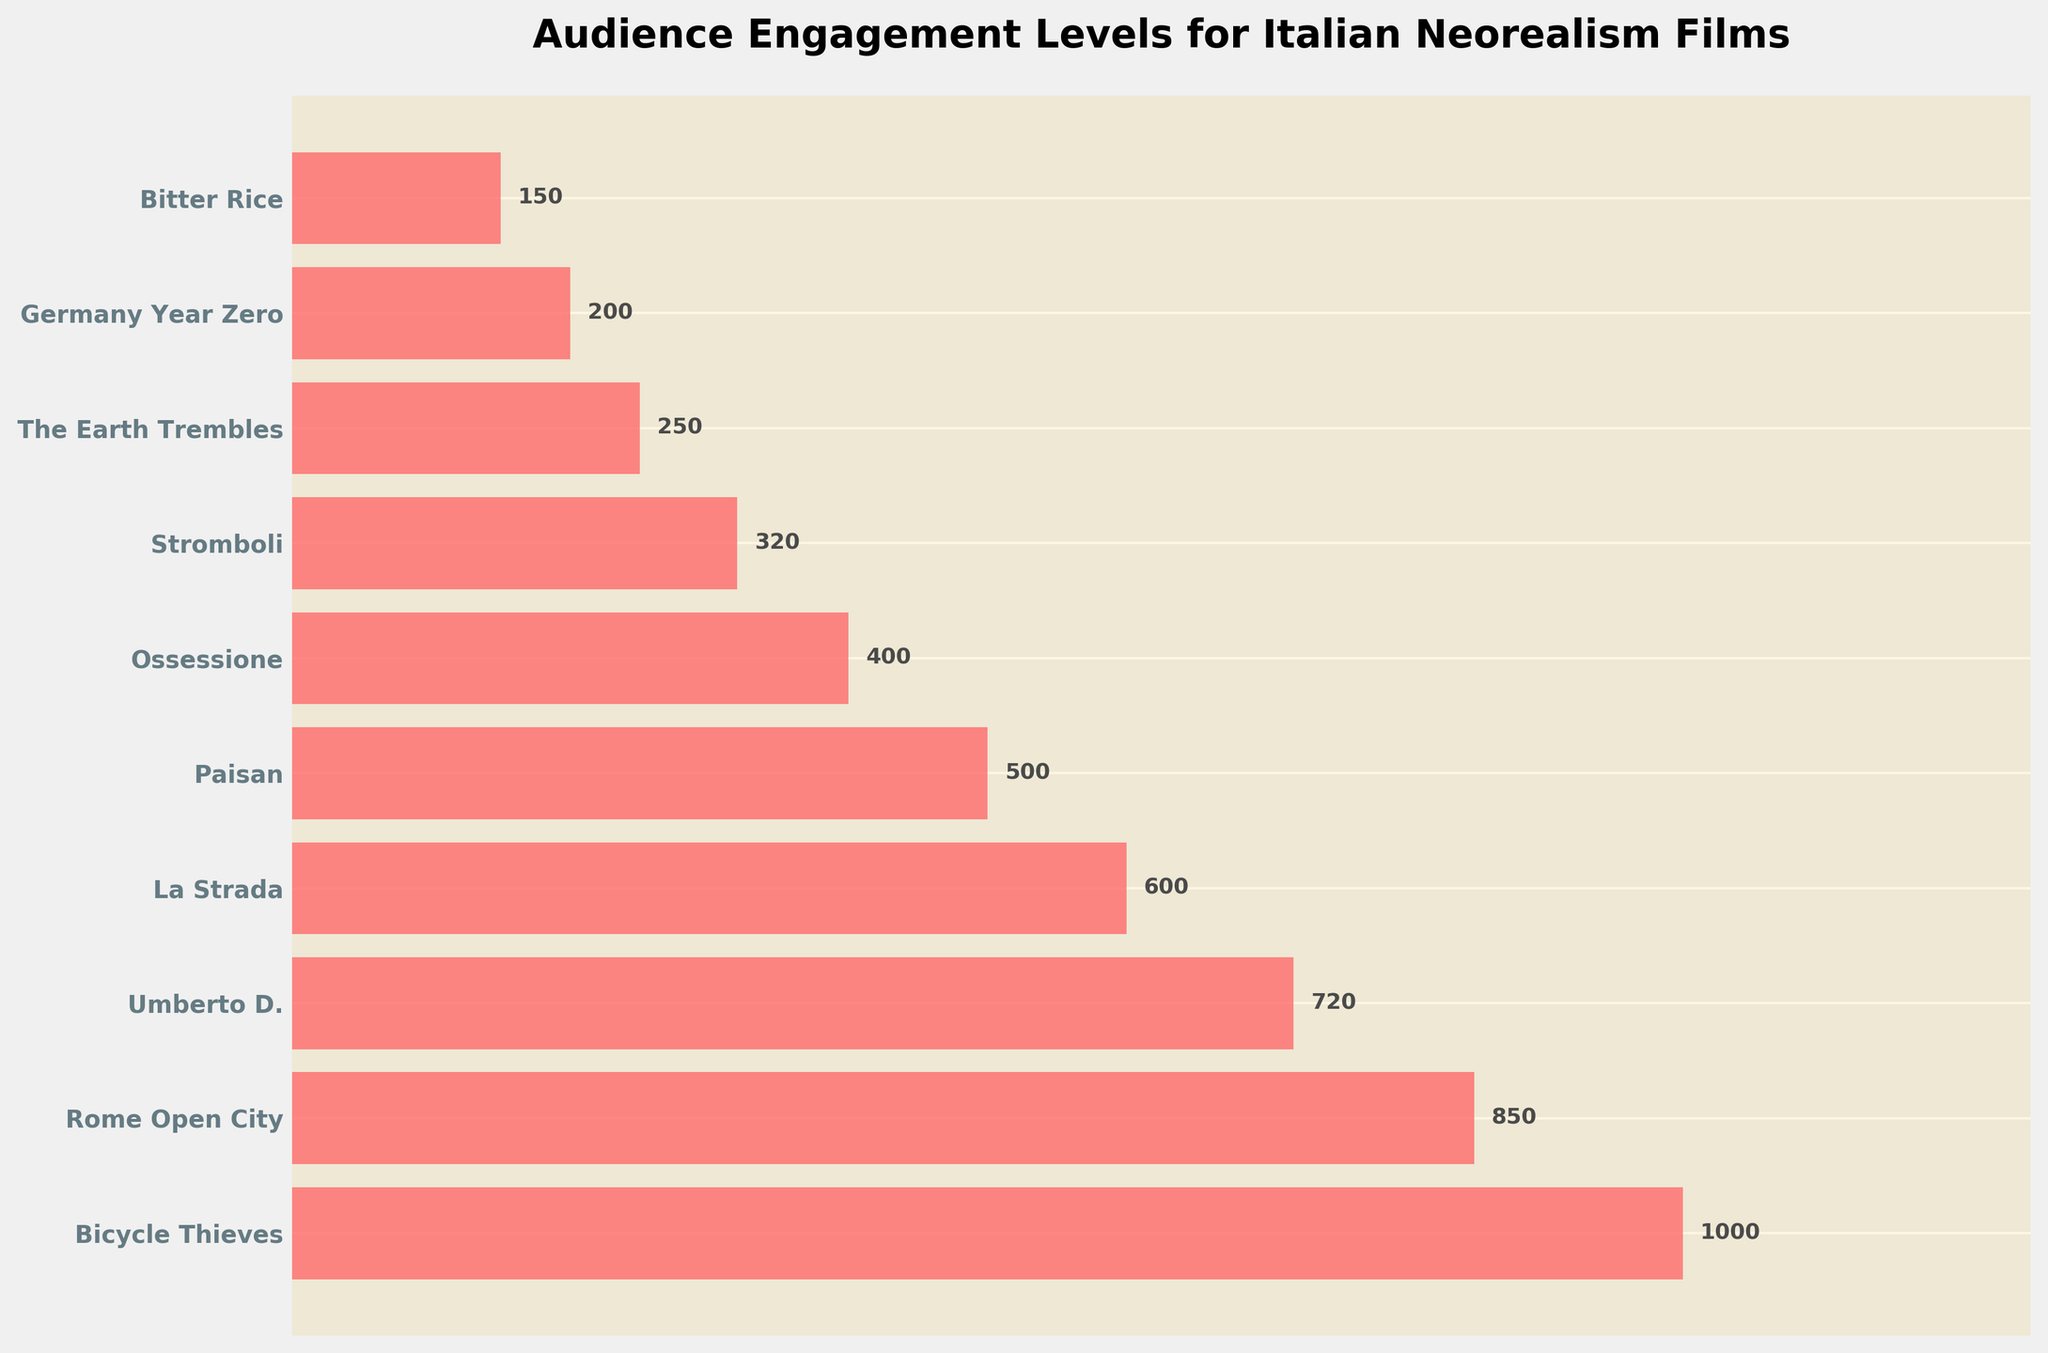What is the title of the figure? The title is displayed at the top of the figure to give an overview of what the chart is about.
Answer: Audience Engagement Levels for Italian Neorealism Films How many films are included in the figure? Count the number of film titles listed along the y-axis.
Answer: 10 Which film has the highest audience engagement level? The longest bar corresponds to the highest engagement level.
Answer: Bicycle Thieves What is the audience engagement level for "La Strada"? Locate the bar corresponding to "La Strada" and read the value displayed next to it.
Answer: 600 What is the difference in engagement level between "Rome Open City" and "Umberto D."? Subtract the engagement level of "Umberto D." from that of "Rome Open City" (850 - 720).
Answer: 130 Which film has less audience engagement: "Stromboli" or "Germany Year Zero"? Compare the lengths of the bars for "Stromboli" and "Germany Year Zero".
Answer: Germany Year Zero What film has an engagement level of 400? Locate the bar with the value 400.
Answer: Ossessione List the films with engagement levels above 700. Identify bars with engagement levels greater than 700 and list corresponding films.
Answer: Bicycle Thieves, Rome Open City, Umberto D What is the total audience engagement for the top three films? Sum the engagement levels of the top three films (1000 + 850 + 720).
Answer: 2570 Which film is just below "Bicycle Thieves" in terms of audience engagement? Identify the bar immediately below the bar for "Bicycle Thieves".
Answer: Rome Open City 